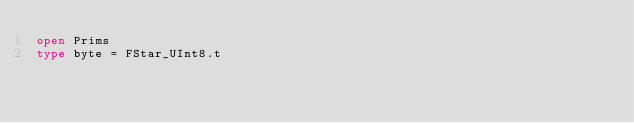<code> <loc_0><loc_0><loc_500><loc_500><_OCaml_>open Prims
type byte = FStar_UInt8.t</code> 